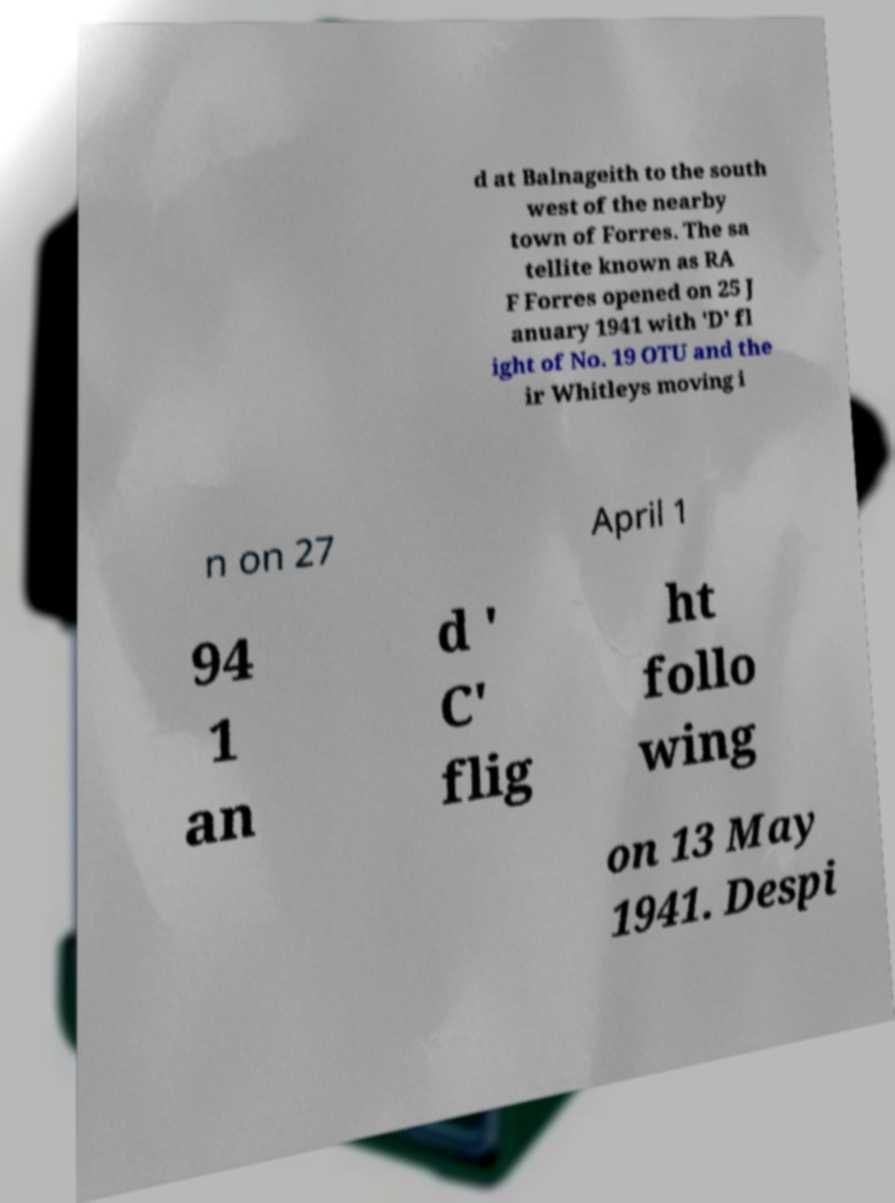Can you accurately transcribe the text from the provided image for me? d at Balnageith to the south west of the nearby town of Forres. The sa tellite known as RA F Forres opened on 25 J anuary 1941 with 'D' fl ight of No. 19 OTU and the ir Whitleys moving i n on 27 April 1 94 1 an d ' C' flig ht follo wing on 13 May 1941. Despi 